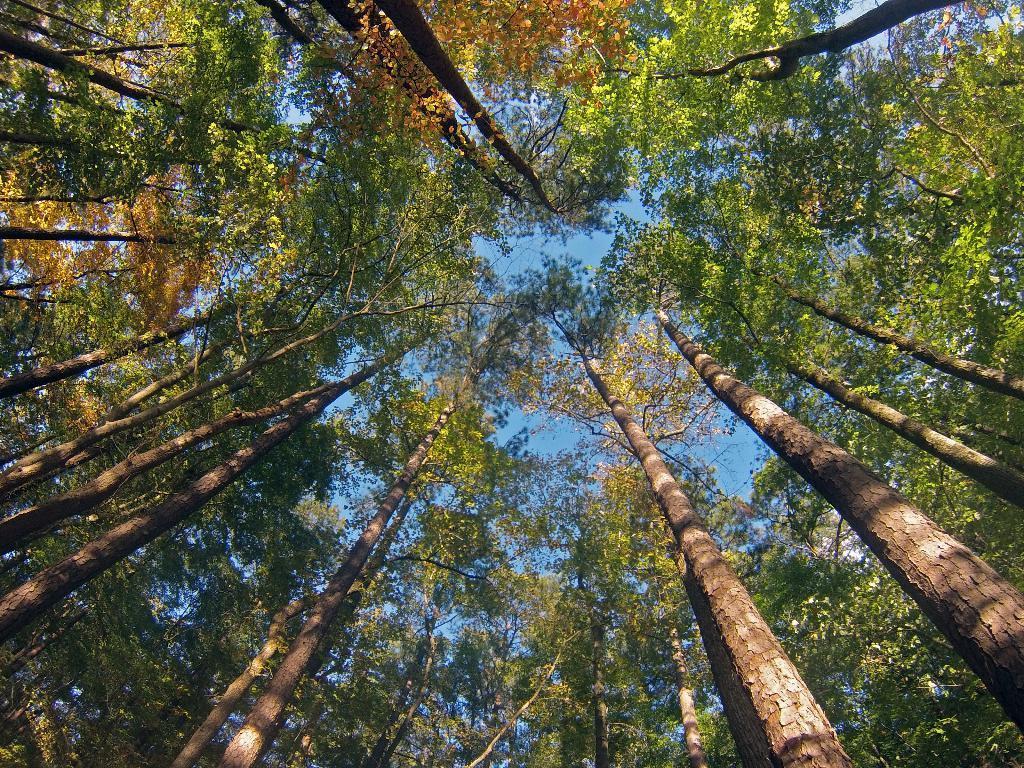Can you describe this image briefly? There are many trees. In the background there is sky. 